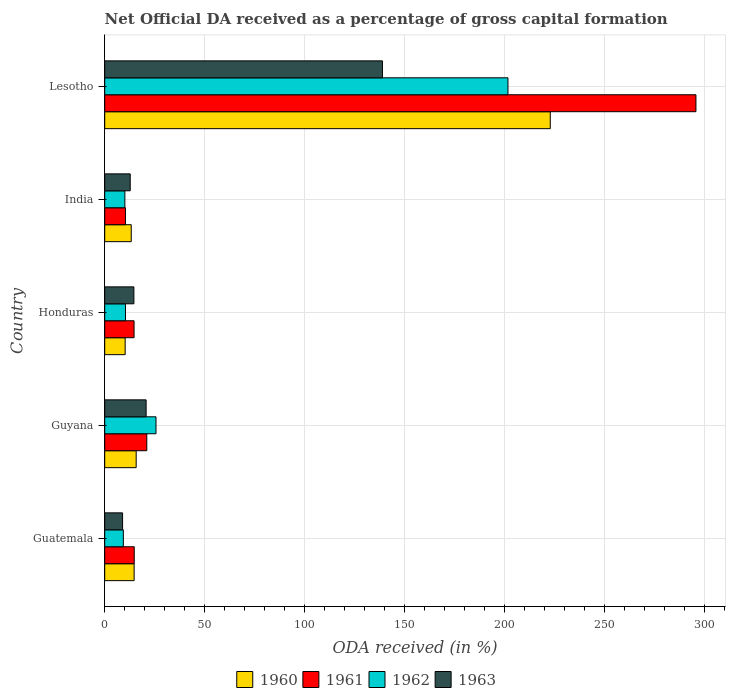How many groups of bars are there?
Make the answer very short. 5. Are the number of bars on each tick of the Y-axis equal?
Keep it short and to the point. Yes. What is the label of the 3rd group of bars from the top?
Provide a short and direct response. Honduras. In how many cases, is the number of bars for a given country not equal to the number of legend labels?
Keep it short and to the point. 0. What is the net ODA received in 1962 in Guatemala?
Offer a very short reply. 9.31. Across all countries, what is the maximum net ODA received in 1961?
Ensure brevity in your answer.  295.71. Across all countries, what is the minimum net ODA received in 1962?
Provide a short and direct response. 9.31. In which country was the net ODA received in 1963 maximum?
Ensure brevity in your answer.  Lesotho. In which country was the net ODA received in 1962 minimum?
Provide a short and direct response. Guatemala. What is the total net ODA received in 1962 in the graph?
Give a very brief answer. 257.14. What is the difference between the net ODA received in 1962 in Guyana and that in Lesotho?
Your response must be concise. -176.05. What is the difference between the net ODA received in 1961 in Guyana and the net ODA received in 1960 in Lesotho?
Your response must be concise. -201.81. What is the average net ODA received in 1960 per country?
Ensure brevity in your answer.  55.36. What is the difference between the net ODA received in 1963 and net ODA received in 1960 in Guatemala?
Offer a terse response. -5.77. In how many countries, is the net ODA received in 1960 greater than 50 %?
Your response must be concise. 1. What is the ratio of the net ODA received in 1961 in Guyana to that in Lesotho?
Provide a short and direct response. 0.07. Is the net ODA received in 1962 in Guyana less than that in India?
Provide a succinct answer. No. What is the difference between the highest and the second highest net ODA received in 1962?
Ensure brevity in your answer.  176.05. What is the difference between the highest and the lowest net ODA received in 1962?
Provide a short and direct response. 192.39. In how many countries, is the net ODA received in 1963 greater than the average net ODA received in 1963 taken over all countries?
Your answer should be very brief. 1. Is the sum of the net ODA received in 1961 in Guatemala and Honduras greater than the maximum net ODA received in 1963 across all countries?
Offer a terse response. No. What does the 4th bar from the bottom in India represents?
Ensure brevity in your answer.  1963. Is it the case that in every country, the sum of the net ODA received in 1960 and net ODA received in 1963 is greater than the net ODA received in 1962?
Keep it short and to the point. Yes. How many bars are there?
Keep it short and to the point. 20. How many countries are there in the graph?
Give a very brief answer. 5. What is the difference between two consecutive major ticks on the X-axis?
Provide a succinct answer. 50. Does the graph contain grids?
Keep it short and to the point. Yes. How many legend labels are there?
Give a very brief answer. 4. What is the title of the graph?
Your response must be concise. Net Official DA received as a percentage of gross capital formation. What is the label or title of the X-axis?
Ensure brevity in your answer.  ODA received (in %). What is the label or title of the Y-axis?
Make the answer very short. Country. What is the ODA received (in %) in 1960 in Guatemala?
Provide a short and direct response. 14.71. What is the ODA received (in %) of 1961 in Guatemala?
Provide a short and direct response. 14.76. What is the ODA received (in %) in 1962 in Guatemala?
Offer a very short reply. 9.31. What is the ODA received (in %) of 1963 in Guatemala?
Your answer should be very brief. 8.93. What is the ODA received (in %) in 1960 in Guyana?
Ensure brevity in your answer.  15.73. What is the ODA received (in %) of 1961 in Guyana?
Keep it short and to the point. 21.05. What is the ODA received (in %) in 1962 in Guyana?
Provide a succinct answer. 25.65. What is the ODA received (in %) of 1963 in Guyana?
Your response must be concise. 20.71. What is the ODA received (in %) in 1960 in Honduras?
Offer a very short reply. 10.23. What is the ODA received (in %) in 1961 in Honduras?
Your response must be concise. 14.68. What is the ODA received (in %) of 1962 in Honduras?
Keep it short and to the point. 10.39. What is the ODA received (in %) of 1963 in Honduras?
Your answer should be very brief. 14.59. What is the ODA received (in %) in 1960 in India?
Ensure brevity in your answer.  13.27. What is the ODA received (in %) of 1961 in India?
Offer a very short reply. 10.37. What is the ODA received (in %) in 1962 in India?
Offer a terse response. 10.08. What is the ODA received (in %) of 1963 in India?
Ensure brevity in your answer.  12.76. What is the ODA received (in %) in 1960 in Lesotho?
Offer a very short reply. 222.86. What is the ODA received (in %) in 1961 in Lesotho?
Offer a very short reply. 295.71. What is the ODA received (in %) of 1962 in Lesotho?
Give a very brief answer. 201.7. What is the ODA received (in %) of 1963 in Lesotho?
Give a very brief answer. 138.92. Across all countries, what is the maximum ODA received (in %) in 1960?
Your response must be concise. 222.86. Across all countries, what is the maximum ODA received (in %) of 1961?
Offer a terse response. 295.71. Across all countries, what is the maximum ODA received (in %) in 1962?
Offer a very short reply. 201.7. Across all countries, what is the maximum ODA received (in %) in 1963?
Your response must be concise. 138.92. Across all countries, what is the minimum ODA received (in %) of 1960?
Ensure brevity in your answer.  10.23. Across all countries, what is the minimum ODA received (in %) in 1961?
Give a very brief answer. 10.37. Across all countries, what is the minimum ODA received (in %) in 1962?
Your answer should be compact. 9.31. Across all countries, what is the minimum ODA received (in %) in 1963?
Give a very brief answer. 8.93. What is the total ODA received (in %) in 1960 in the graph?
Your response must be concise. 276.79. What is the total ODA received (in %) in 1961 in the graph?
Provide a succinct answer. 356.57. What is the total ODA received (in %) of 1962 in the graph?
Your answer should be compact. 257.14. What is the total ODA received (in %) in 1963 in the graph?
Provide a short and direct response. 195.91. What is the difference between the ODA received (in %) in 1960 in Guatemala and that in Guyana?
Offer a terse response. -1.02. What is the difference between the ODA received (in %) of 1961 in Guatemala and that in Guyana?
Give a very brief answer. -6.29. What is the difference between the ODA received (in %) of 1962 in Guatemala and that in Guyana?
Your answer should be compact. -16.34. What is the difference between the ODA received (in %) of 1963 in Guatemala and that in Guyana?
Give a very brief answer. -11.78. What is the difference between the ODA received (in %) in 1960 in Guatemala and that in Honduras?
Give a very brief answer. 4.48. What is the difference between the ODA received (in %) in 1961 in Guatemala and that in Honduras?
Offer a very short reply. 0.08. What is the difference between the ODA received (in %) in 1962 in Guatemala and that in Honduras?
Your answer should be very brief. -1.08. What is the difference between the ODA received (in %) in 1963 in Guatemala and that in Honduras?
Provide a short and direct response. -5.66. What is the difference between the ODA received (in %) in 1960 in Guatemala and that in India?
Ensure brevity in your answer.  1.44. What is the difference between the ODA received (in %) of 1961 in Guatemala and that in India?
Ensure brevity in your answer.  4.39. What is the difference between the ODA received (in %) of 1962 in Guatemala and that in India?
Your response must be concise. -0.77. What is the difference between the ODA received (in %) of 1963 in Guatemala and that in India?
Your answer should be compact. -3.82. What is the difference between the ODA received (in %) in 1960 in Guatemala and that in Lesotho?
Provide a short and direct response. -208.15. What is the difference between the ODA received (in %) in 1961 in Guatemala and that in Lesotho?
Ensure brevity in your answer.  -280.95. What is the difference between the ODA received (in %) of 1962 in Guatemala and that in Lesotho?
Keep it short and to the point. -192.39. What is the difference between the ODA received (in %) in 1963 in Guatemala and that in Lesotho?
Your answer should be compact. -129.98. What is the difference between the ODA received (in %) of 1960 in Guyana and that in Honduras?
Make the answer very short. 5.5. What is the difference between the ODA received (in %) of 1961 in Guyana and that in Honduras?
Keep it short and to the point. 6.37. What is the difference between the ODA received (in %) in 1962 in Guyana and that in Honduras?
Offer a terse response. 15.26. What is the difference between the ODA received (in %) of 1963 in Guyana and that in Honduras?
Give a very brief answer. 6.12. What is the difference between the ODA received (in %) of 1960 in Guyana and that in India?
Offer a terse response. 2.46. What is the difference between the ODA received (in %) of 1961 in Guyana and that in India?
Your response must be concise. 10.67. What is the difference between the ODA received (in %) in 1962 in Guyana and that in India?
Offer a terse response. 15.57. What is the difference between the ODA received (in %) of 1963 in Guyana and that in India?
Keep it short and to the point. 7.96. What is the difference between the ODA received (in %) in 1960 in Guyana and that in Lesotho?
Your answer should be compact. -207.13. What is the difference between the ODA received (in %) in 1961 in Guyana and that in Lesotho?
Your answer should be compact. -274.67. What is the difference between the ODA received (in %) of 1962 in Guyana and that in Lesotho?
Provide a succinct answer. -176.05. What is the difference between the ODA received (in %) in 1963 in Guyana and that in Lesotho?
Your answer should be compact. -118.2. What is the difference between the ODA received (in %) in 1960 in Honduras and that in India?
Make the answer very short. -3.05. What is the difference between the ODA received (in %) in 1961 in Honduras and that in India?
Give a very brief answer. 4.3. What is the difference between the ODA received (in %) in 1962 in Honduras and that in India?
Offer a terse response. 0.31. What is the difference between the ODA received (in %) in 1963 in Honduras and that in India?
Your answer should be compact. 1.84. What is the difference between the ODA received (in %) of 1960 in Honduras and that in Lesotho?
Your response must be concise. -212.63. What is the difference between the ODA received (in %) of 1961 in Honduras and that in Lesotho?
Your response must be concise. -281.04. What is the difference between the ODA received (in %) in 1962 in Honduras and that in Lesotho?
Ensure brevity in your answer.  -191.31. What is the difference between the ODA received (in %) of 1963 in Honduras and that in Lesotho?
Give a very brief answer. -124.33. What is the difference between the ODA received (in %) in 1960 in India and that in Lesotho?
Provide a short and direct response. -209.59. What is the difference between the ODA received (in %) in 1961 in India and that in Lesotho?
Make the answer very short. -285.34. What is the difference between the ODA received (in %) of 1962 in India and that in Lesotho?
Your answer should be very brief. -191.62. What is the difference between the ODA received (in %) in 1963 in India and that in Lesotho?
Your answer should be very brief. -126.16. What is the difference between the ODA received (in %) of 1960 in Guatemala and the ODA received (in %) of 1961 in Guyana?
Make the answer very short. -6.34. What is the difference between the ODA received (in %) in 1960 in Guatemala and the ODA received (in %) in 1962 in Guyana?
Your answer should be compact. -10.95. What is the difference between the ODA received (in %) in 1960 in Guatemala and the ODA received (in %) in 1963 in Guyana?
Keep it short and to the point. -6.01. What is the difference between the ODA received (in %) in 1961 in Guatemala and the ODA received (in %) in 1962 in Guyana?
Your answer should be compact. -10.89. What is the difference between the ODA received (in %) in 1961 in Guatemala and the ODA received (in %) in 1963 in Guyana?
Your answer should be very brief. -5.95. What is the difference between the ODA received (in %) in 1962 in Guatemala and the ODA received (in %) in 1963 in Guyana?
Offer a very short reply. -11.4. What is the difference between the ODA received (in %) of 1960 in Guatemala and the ODA received (in %) of 1961 in Honduras?
Make the answer very short. 0.03. What is the difference between the ODA received (in %) of 1960 in Guatemala and the ODA received (in %) of 1962 in Honduras?
Provide a short and direct response. 4.32. What is the difference between the ODA received (in %) in 1960 in Guatemala and the ODA received (in %) in 1963 in Honduras?
Keep it short and to the point. 0.12. What is the difference between the ODA received (in %) of 1961 in Guatemala and the ODA received (in %) of 1962 in Honduras?
Offer a terse response. 4.37. What is the difference between the ODA received (in %) of 1961 in Guatemala and the ODA received (in %) of 1963 in Honduras?
Your answer should be compact. 0.17. What is the difference between the ODA received (in %) of 1962 in Guatemala and the ODA received (in %) of 1963 in Honduras?
Give a very brief answer. -5.28. What is the difference between the ODA received (in %) in 1960 in Guatemala and the ODA received (in %) in 1961 in India?
Your answer should be very brief. 4.33. What is the difference between the ODA received (in %) in 1960 in Guatemala and the ODA received (in %) in 1962 in India?
Provide a succinct answer. 4.63. What is the difference between the ODA received (in %) of 1960 in Guatemala and the ODA received (in %) of 1963 in India?
Offer a very short reply. 1.95. What is the difference between the ODA received (in %) in 1961 in Guatemala and the ODA received (in %) in 1962 in India?
Offer a terse response. 4.68. What is the difference between the ODA received (in %) in 1961 in Guatemala and the ODA received (in %) in 1963 in India?
Ensure brevity in your answer.  2. What is the difference between the ODA received (in %) of 1962 in Guatemala and the ODA received (in %) of 1963 in India?
Your answer should be very brief. -3.44. What is the difference between the ODA received (in %) of 1960 in Guatemala and the ODA received (in %) of 1961 in Lesotho?
Your answer should be very brief. -281.01. What is the difference between the ODA received (in %) in 1960 in Guatemala and the ODA received (in %) in 1962 in Lesotho?
Your response must be concise. -186.99. What is the difference between the ODA received (in %) of 1960 in Guatemala and the ODA received (in %) of 1963 in Lesotho?
Give a very brief answer. -124.21. What is the difference between the ODA received (in %) of 1961 in Guatemala and the ODA received (in %) of 1962 in Lesotho?
Ensure brevity in your answer.  -186.94. What is the difference between the ODA received (in %) of 1961 in Guatemala and the ODA received (in %) of 1963 in Lesotho?
Provide a succinct answer. -124.16. What is the difference between the ODA received (in %) in 1962 in Guatemala and the ODA received (in %) in 1963 in Lesotho?
Your answer should be very brief. -129.6. What is the difference between the ODA received (in %) in 1960 in Guyana and the ODA received (in %) in 1961 in Honduras?
Your answer should be compact. 1.05. What is the difference between the ODA received (in %) of 1960 in Guyana and the ODA received (in %) of 1962 in Honduras?
Offer a very short reply. 5.34. What is the difference between the ODA received (in %) in 1960 in Guyana and the ODA received (in %) in 1963 in Honduras?
Your answer should be very brief. 1.14. What is the difference between the ODA received (in %) of 1961 in Guyana and the ODA received (in %) of 1962 in Honduras?
Ensure brevity in your answer.  10.66. What is the difference between the ODA received (in %) in 1961 in Guyana and the ODA received (in %) in 1963 in Honduras?
Keep it short and to the point. 6.46. What is the difference between the ODA received (in %) of 1962 in Guyana and the ODA received (in %) of 1963 in Honduras?
Give a very brief answer. 11.06. What is the difference between the ODA received (in %) in 1960 in Guyana and the ODA received (in %) in 1961 in India?
Provide a succinct answer. 5.36. What is the difference between the ODA received (in %) of 1960 in Guyana and the ODA received (in %) of 1962 in India?
Your answer should be compact. 5.65. What is the difference between the ODA received (in %) in 1960 in Guyana and the ODA received (in %) in 1963 in India?
Offer a very short reply. 2.97. What is the difference between the ODA received (in %) in 1961 in Guyana and the ODA received (in %) in 1962 in India?
Ensure brevity in your answer.  10.97. What is the difference between the ODA received (in %) of 1961 in Guyana and the ODA received (in %) of 1963 in India?
Ensure brevity in your answer.  8.29. What is the difference between the ODA received (in %) of 1962 in Guyana and the ODA received (in %) of 1963 in India?
Give a very brief answer. 12.9. What is the difference between the ODA received (in %) of 1960 in Guyana and the ODA received (in %) of 1961 in Lesotho?
Provide a succinct answer. -279.98. What is the difference between the ODA received (in %) of 1960 in Guyana and the ODA received (in %) of 1962 in Lesotho?
Make the answer very short. -185.97. What is the difference between the ODA received (in %) in 1960 in Guyana and the ODA received (in %) in 1963 in Lesotho?
Keep it short and to the point. -123.19. What is the difference between the ODA received (in %) of 1961 in Guyana and the ODA received (in %) of 1962 in Lesotho?
Offer a very short reply. -180.65. What is the difference between the ODA received (in %) in 1961 in Guyana and the ODA received (in %) in 1963 in Lesotho?
Your answer should be very brief. -117.87. What is the difference between the ODA received (in %) of 1962 in Guyana and the ODA received (in %) of 1963 in Lesotho?
Ensure brevity in your answer.  -113.26. What is the difference between the ODA received (in %) of 1960 in Honduras and the ODA received (in %) of 1961 in India?
Your response must be concise. -0.15. What is the difference between the ODA received (in %) of 1960 in Honduras and the ODA received (in %) of 1962 in India?
Your answer should be compact. 0.14. What is the difference between the ODA received (in %) in 1960 in Honduras and the ODA received (in %) in 1963 in India?
Your answer should be very brief. -2.53. What is the difference between the ODA received (in %) of 1961 in Honduras and the ODA received (in %) of 1962 in India?
Give a very brief answer. 4.6. What is the difference between the ODA received (in %) in 1961 in Honduras and the ODA received (in %) in 1963 in India?
Your response must be concise. 1.92. What is the difference between the ODA received (in %) of 1962 in Honduras and the ODA received (in %) of 1963 in India?
Keep it short and to the point. -2.37. What is the difference between the ODA received (in %) in 1960 in Honduras and the ODA received (in %) in 1961 in Lesotho?
Your answer should be compact. -285.49. What is the difference between the ODA received (in %) of 1960 in Honduras and the ODA received (in %) of 1962 in Lesotho?
Your answer should be very brief. -191.48. What is the difference between the ODA received (in %) in 1960 in Honduras and the ODA received (in %) in 1963 in Lesotho?
Your response must be concise. -128.69. What is the difference between the ODA received (in %) of 1961 in Honduras and the ODA received (in %) of 1962 in Lesotho?
Give a very brief answer. -187.02. What is the difference between the ODA received (in %) of 1961 in Honduras and the ODA received (in %) of 1963 in Lesotho?
Provide a succinct answer. -124.24. What is the difference between the ODA received (in %) in 1962 in Honduras and the ODA received (in %) in 1963 in Lesotho?
Give a very brief answer. -128.53. What is the difference between the ODA received (in %) in 1960 in India and the ODA received (in %) in 1961 in Lesotho?
Give a very brief answer. -282.44. What is the difference between the ODA received (in %) in 1960 in India and the ODA received (in %) in 1962 in Lesotho?
Ensure brevity in your answer.  -188.43. What is the difference between the ODA received (in %) in 1960 in India and the ODA received (in %) in 1963 in Lesotho?
Provide a short and direct response. -125.65. What is the difference between the ODA received (in %) in 1961 in India and the ODA received (in %) in 1962 in Lesotho?
Your response must be concise. -191.33. What is the difference between the ODA received (in %) of 1961 in India and the ODA received (in %) of 1963 in Lesotho?
Give a very brief answer. -128.54. What is the difference between the ODA received (in %) of 1962 in India and the ODA received (in %) of 1963 in Lesotho?
Offer a terse response. -128.84. What is the average ODA received (in %) of 1960 per country?
Provide a short and direct response. 55.36. What is the average ODA received (in %) of 1961 per country?
Provide a succinct answer. 71.31. What is the average ODA received (in %) of 1962 per country?
Give a very brief answer. 51.43. What is the average ODA received (in %) in 1963 per country?
Your answer should be very brief. 39.18. What is the difference between the ODA received (in %) of 1960 and ODA received (in %) of 1961 in Guatemala?
Make the answer very short. -0.05. What is the difference between the ODA received (in %) of 1960 and ODA received (in %) of 1962 in Guatemala?
Your answer should be compact. 5.39. What is the difference between the ODA received (in %) of 1960 and ODA received (in %) of 1963 in Guatemala?
Your answer should be compact. 5.77. What is the difference between the ODA received (in %) in 1961 and ODA received (in %) in 1962 in Guatemala?
Provide a succinct answer. 5.45. What is the difference between the ODA received (in %) of 1961 and ODA received (in %) of 1963 in Guatemala?
Keep it short and to the point. 5.83. What is the difference between the ODA received (in %) of 1962 and ODA received (in %) of 1963 in Guatemala?
Make the answer very short. 0.38. What is the difference between the ODA received (in %) of 1960 and ODA received (in %) of 1961 in Guyana?
Keep it short and to the point. -5.32. What is the difference between the ODA received (in %) of 1960 and ODA received (in %) of 1962 in Guyana?
Offer a very short reply. -9.92. What is the difference between the ODA received (in %) in 1960 and ODA received (in %) in 1963 in Guyana?
Offer a terse response. -4.98. What is the difference between the ODA received (in %) of 1961 and ODA received (in %) of 1962 in Guyana?
Your answer should be very brief. -4.61. What is the difference between the ODA received (in %) in 1961 and ODA received (in %) in 1963 in Guyana?
Your answer should be very brief. 0.33. What is the difference between the ODA received (in %) in 1962 and ODA received (in %) in 1963 in Guyana?
Offer a terse response. 4.94. What is the difference between the ODA received (in %) in 1960 and ODA received (in %) in 1961 in Honduras?
Your answer should be compact. -4.45. What is the difference between the ODA received (in %) of 1960 and ODA received (in %) of 1962 in Honduras?
Offer a terse response. -0.16. What is the difference between the ODA received (in %) of 1960 and ODA received (in %) of 1963 in Honduras?
Your answer should be very brief. -4.37. What is the difference between the ODA received (in %) in 1961 and ODA received (in %) in 1962 in Honduras?
Give a very brief answer. 4.29. What is the difference between the ODA received (in %) in 1961 and ODA received (in %) in 1963 in Honduras?
Make the answer very short. 0.09. What is the difference between the ODA received (in %) in 1962 and ODA received (in %) in 1963 in Honduras?
Provide a short and direct response. -4.2. What is the difference between the ODA received (in %) in 1960 and ODA received (in %) in 1961 in India?
Make the answer very short. 2.9. What is the difference between the ODA received (in %) in 1960 and ODA received (in %) in 1962 in India?
Your answer should be very brief. 3.19. What is the difference between the ODA received (in %) of 1960 and ODA received (in %) of 1963 in India?
Provide a short and direct response. 0.52. What is the difference between the ODA received (in %) of 1961 and ODA received (in %) of 1962 in India?
Keep it short and to the point. 0.29. What is the difference between the ODA received (in %) of 1961 and ODA received (in %) of 1963 in India?
Your answer should be compact. -2.38. What is the difference between the ODA received (in %) of 1962 and ODA received (in %) of 1963 in India?
Your answer should be very brief. -2.68. What is the difference between the ODA received (in %) of 1960 and ODA received (in %) of 1961 in Lesotho?
Keep it short and to the point. -72.86. What is the difference between the ODA received (in %) of 1960 and ODA received (in %) of 1962 in Lesotho?
Provide a short and direct response. 21.16. What is the difference between the ODA received (in %) in 1960 and ODA received (in %) in 1963 in Lesotho?
Provide a short and direct response. 83.94. What is the difference between the ODA received (in %) of 1961 and ODA received (in %) of 1962 in Lesotho?
Offer a very short reply. 94.01. What is the difference between the ODA received (in %) in 1961 and ODA received (in %) in 1963 in Lesotho?
Your answer should be compact. 156.8. What is the difference between the ODA received (in %) of 1962 and ODA received (in %) of 1963 in Lesotho?
Ensure brevity in your answer.  62.78. What is the ratio of the ODA received (in %) of 1960 in Guatemala to that in Guyana?
Make the answer very short. 0.94. What is the ratio of the ODA received (in %) in 1961 in Guatemala to that in Guyana?
Keep it short and to the point. 0.7. What is the ratio of the ODA received (in %) in 1962 in Guatemala to that in Guyana?
Your response must be concise. 0.36. What is the ratio of the ODA received (in %) in 1963 in Guatemala to that in Guyana?
Offer a very short reply. 0.43. What is the ratio of the ODA received (in %) in 1960 in Guatemala to that in Honduras?
Make the answer very short. 1.44. What is the ratio of the ODA received (in %) of 1961 in Guatemala to that in Honduras?
Make the answer very short. 1.01. What is the ratio of the ODA received (in %) in 1962 in Guatemala to that in Honduras?
Provide a succinct answer. 0.9. What is the ratio of the ODA received (in %) of 1963 in Guatemala to that in Honduras?
Offer a very short reply. 0.61. What is the ratio of the ODA received (in %) of 1960 in Guatemala to that in India?
Your response must be concise. 1.11. What is the ratio of the ODA received (in %) in 1961 in Guatemala to that in India?
Ensure brevity in your answer.  1.42. What is the ratio of the ODA received (in %) in 1962 in Guatemala to that in India?
Offer a very short reply. 0.92. What is the ratio of the ODA received (in %) of 1963 in Guatemala to that in India?
Ensure brevity in your answer.  0.7. What is the ratio of the ODA received (in %) of 1960 in Guatemala to that in Lesotho?
Your answer should be compact. 0.07. What is the ratio of the ODA received (in %) of 1961 in Guatemala to that in Lesotho?
Offer a very short reply. 0.05. What is the ratio of the ODA received (in %) in 1962 in Guatemala to that in Lesotho?
Ensure brevity in your answer.  0.05. What is the ratio of the ODA received (in %) of 1963 in Guatemala to that in Lesotho?
Keep it short and to the point. 0.06. What is the ratio of the ODA received (in %) of 1960 in Guyana to that in Honduras?
Your answer should be very brief. 1.54. What is the ratio of the ODA received (in %) of 1961 in Guyana to that in Honduras?
Provide a succinct answer. 1.43. What is the ratio of the ODA received (in %) of 1962 in Guyana to that in Honduras?
Your answer should be very brief. 2.47. What is the ratio of the ODA received (in %) in 1963 in Guyana to that in Honduras?
Keep it short and to the point. 1.42. What is the ratio of the ODA received (in %) of 1960 in Guyana to that in India?
Your response must be concise. 1.19. What is the ratio of the ODA received (in %) in 1961 in Guyana to that in India?
Make the answer very short. 2.03. What is the ratio of the ODA received (in %) of 1962 in Guyana to that in India?
Keep it short and to the point. 2.54. What is the ratio of the ODA received (in %) of 1963 in Guyana to that in India?
Give a very brief answer. 1.62. What is the ratio of the ODA received (in %) of 1960 in Guyana to that in Lesotho?
Provide a short and direct response. 0.07. What is the ratio of the ODA received (in %) in 1961 in Guyana to that in Lesotho?
Provide a succinct answer. 0.07. What is the ratio of the ODA received (in %) of 1962 in Guyana to that in Lesotho?
Give a very brief answer. 0.13. What is the ratio of the ODA received (in %) in 1963 in Guyana to that in Lesotho?
Give a very brief answer. 0.15. What is the ratio of the ODA received (in %) in 1960 in Honduras to that in India?
Keep it short and to the point. 0.77. What is the ratio of the ODA received (in %) of 1961 in Honduras to that in India?
Keep it short and to the point. 1.41. What is the ratio of the ODA received (in %) in 1962 in Honduras to that in India?
Your answer should be very brief. 1.03. What is the ratio of the ODA received (in %) in 1963 in Honduras to that in India?
Make the answer very short. 1.14. What is the ratio of the ODA received (in %) of 1960 in Honduras to that in Lesotho?
Your answer should be compact. 0.05. What is the ratio of the ODA received (in %) in 1961 in Honduras to that in Lesotho?
Offer a terse response. 0.05. What is the ratio of the ODA received (in %) of 1962 in Honduras to that in Lesotho?
Give a very brief answer. 0.05. What is the ratio of the ODA received (in %) of 1963 in Honduras to that in Lesotho?
Provide a succinct answer. 0.1. What is the ratio of the ODA received (in %) of 1960 in India to that in Lesotho?
Provide a succinct answer. 0.06. What is the ratio of the ODA received (in %) of 1961 in India to that in Lesotho?
Offer a very short reply. 0.04. What is the ratio of the ODA received (in %) in 1963 in India to that in Lesotho?
Your answer should be very brief. 0.09. What is the difference between the highest and the second highest ODA received (in %) of 1960?
Make the answer very short. 207.13. What is the difference between the highest and the second highest ODA received (in %) of 1961?
Offer a very short reply. 274.67. What is the difference between the highest and the second highest ODA received (in %) of 1962?
Give a very brief answer. 176.05. What is the difference between the highest and the second highest ODA received (in %) of 1963?
Your response must be concise. 118.2. What is the difference between the highest and the lowest ODA received (in %) of 1960?
Your response must be concise. 212.63. What is the difference between the highest and the lowest ODA received (in %) of 1961?
Give a very brief answer. 285.34. What is the difference between the highest and the lowest ODA received (in %) of 1962?
Offer a terse response. 192.39. What is the difference between the highest and the lowest ODA received (in %) of 1963?
Offer a terse response. 129.98. 